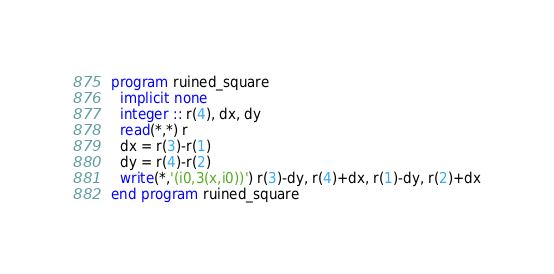Convert code to text. <code><loc_0><loc_0><loc_500><loc_500><_FORTRAN_>program ruined_square
  implicit none
  integer :: r(4), dx, dy
  read(*,*) r
  dx = r(3)-r(1)
  dy = r(4)-r(2)
  write(*,'(i0,3(x,i0))') r(3)-dy, r(4)+dx, r(1)-dy, r(2)+dx
end program ruined_square</code> 